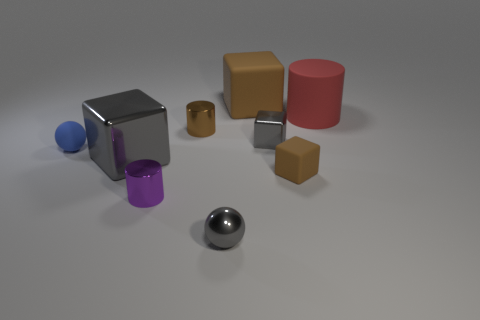Subtract all blue cylinders. Subtract all cyan cubes. How many cylinders are left? 3 Subtract all purple balls. How many red cylinders are left? 1 Add 4 small grays. How many objects exist? 0 Subtract all tiny brown matte things. Subtract all small blue balls. How many objects are left? 7 Add 2 brown things. How many brown things are left? 5 Add 7 big rubber blocks. How many big rubber blocks exist? 8 Add 1 small purple metal cylinders. How many objects exist? 10 Subtract all blue balls. How many balls are left? 1 Subtract all tiny gray metal blocks. How many blocks are left? 3 Subtract 0 blue cylinders. How many objects are left? 9 